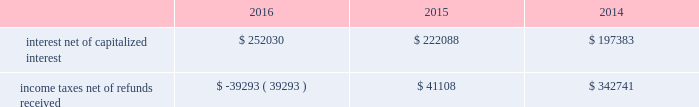The diluted earnings per share calculation excludes stock options , sars , restricted stock and units and performance units and stock that were anti-dilutive .
Shares underlying the excluded stock options and sars totaled 10.3 million , 10.2 million and 0.7 million for the years ended december 31 , 2016 , 2015 and 2014 , respectively .
For the years ended december 31 , 2016 and 2015 , respectively , 4.5 million and 5.3 million shares of restricted stock and restricted stock units and performance units and performance stock were excluded .
10 .
Supplemental cash flow information net cash paid for interest and income taxes was as follows for the years ended december 31 , 2016 , 2015 and 2014 ( in thousands ) : .
Eog's accrued capital expenditures at december 31 , 2016 , 2015 and 2014 were $ 388 million , $ 416 million and $ 972 million , respectively .
Non-cash investing activities for the year ended december 31 , 2016 , included $ 3834 million in non-cash additions to eog's oil and gas properties related to the yates transaction ( see note 17 ) .
Non-cash investing activities for the year ended december 31 , 2014 included non-cash additions of $ 5 million to eog's oil and gas properties as a result of property exchanges .
11 .
Business segment information eog's operations are all crude oil and natural gas exploration and production related .
The segment reporting topic of the asc establishes standards for reporting information about operating segments in annual financial statements .
Operating segments are defined as components of an enterprise about which separate financial information is available and evaluated regularly by the chief operating decision maker , or decision-making group , in deciding how to allocate resources and in assessing performance .
Eog's chief operating decision-making process is informal and involves the chairman of the board and chief executive officer and other key officers .
This group routinely reviews and makes operating decisions related to significant issues associated with each of eog's major producing areas in the united states , trinidad , the united kingdom and china .
For segment reporting purposes , the chief operating decision maker considers the major united states producing areas to be one operating segment. .
What is the increase observed in the interest net of capitalized interest during 2015 and 2016? 
Rationale: it is the interest net of capitalized interest of 2016 divided by the 2015's , then subtracted 1 and turned into a percentage .
Computations: ((252030 / 222088) - 1)
Answer: 0.13482. 